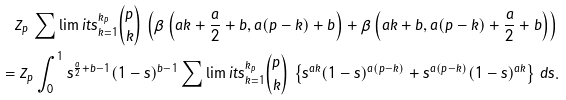Convert formula to latex. <formula><loc_0><loc_0><loc_500><loc_500>Z _ { p } \, \sum \lim i t s _ { k = 1 } ^ { k _ { p } } { { p } \choose { k } } \, \left ( \beta \left ( a k + \frac { a } { 2 } + b , a ( p - k ) + b \right ) + \beta \left ( a k + b , a ( p - k ) + \frac { a } { 2 } + b \right ) \right ) \, \\ = Z _ { p } \int _ { 0 } ^ { 1 } s ^ { \frac { a } { 2 } + b - 1 } ( 1 - s ) ^ { b - 1 } \sum \lim i t s _ { k = 1 } ^ { k _ { p } } { { p } \choose { k } } \, \left \{ s ^ { a k } ( 1 - s ) ^ { a ( p - k ) } + s ^ { a ( p - k ) } ( 1 - s ) ^ { a k } \right \} \, d s .</formula> 